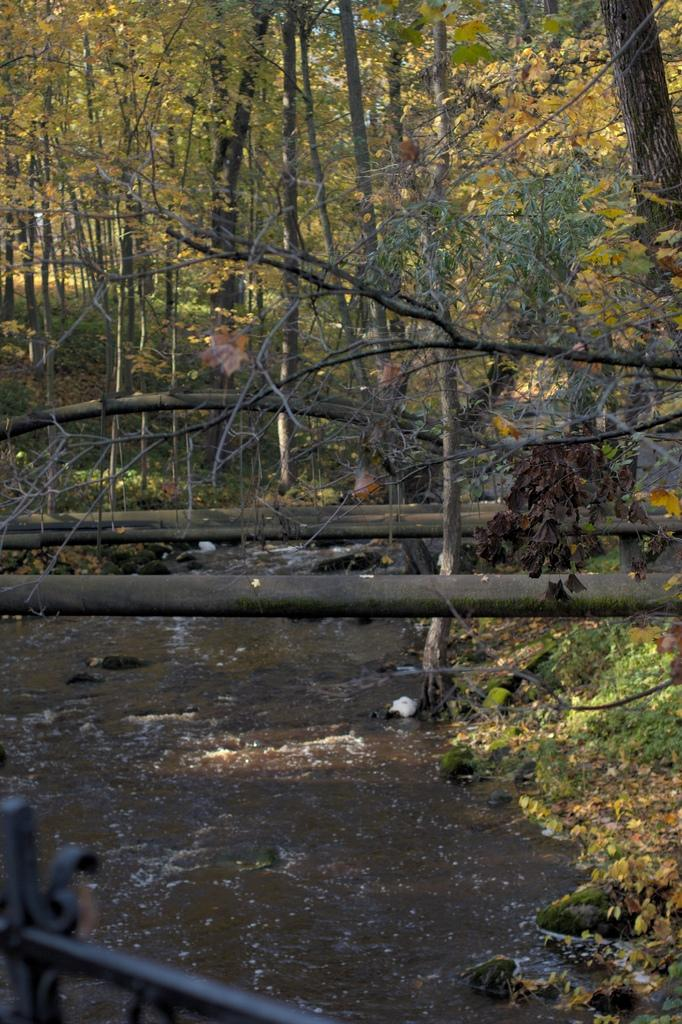What type of natural elements can be seen in the image? There are stones and water in the image. What type of vegetation is present on the ground in the image? There are plants on the ground in the image. What type of objects can be seen in the image? There are objects in the image. What type of natural elements can be seen in the background of the image? There are trees in the background of the image. What type of locket can be seen hanging from the tree in the image? There is no locket present in the image; it only features stones, water, plants, objects, and trees in the background. 